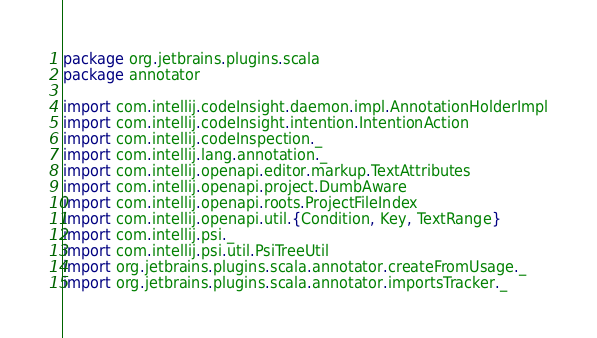<code> <loc_0><loc_0><loc_500><loc_500><_Scala_>package org.jetbrains.plugins.scala
package annotator

import com.intellij.codeInsight.daemon.impl.AnnotationHolderImpl
import com.intellij.codeInsight.intention.IntentionAction
import com.intellij.codeInspection._
import com.intellij.lang.annotation._
import com.intellij.openapi.editor.markup.TextAttributes
import com.intellij.openapi.project.DumbAware
import com.intellij.openapi.roots.ProjectFileIndex
import com.intellij.openapi.util.{Condition, Key, TextRange}
import com.intellij.psi._
import com.intellij.psi.util.PsiTreeUtil
import org.jetbrains.plugins.scala.annotator.createFromUsage._
import org.jetbrains.plugins.scala.annotator.importsTracker._</code> 